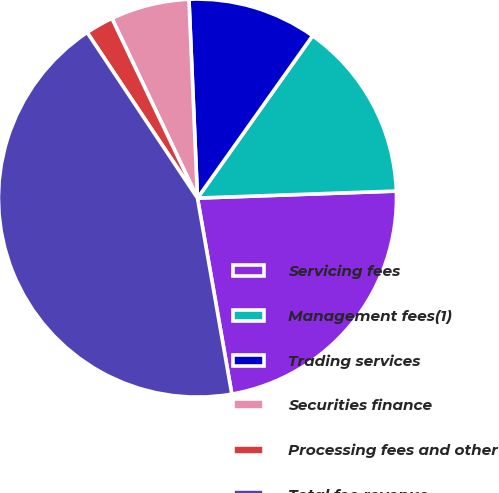<chart> <loc_0><loc_0><loc_500><loc_500><pie_chart><fcel>Servicing fees<fcel>Management fees(1)<fcel>Trading services<fcel>Securities finance<fcel>Processing fees and other<fcel>Total fee revenue<nl><fcel>22.8%<fcel>14.62%<fcel>10.5%<fcel>6.39%<fcel>2.28%<fcel>43.41%<nl></chart> 